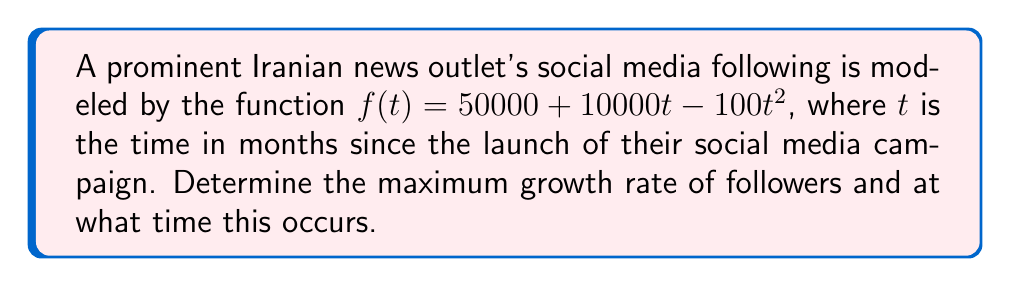Can you answer this question? To solve this problem, we'll follow these steps:

1) The growth rate is given by the derivative of the function. Let's find $f'(t)$:

   $f'(t) = 10000 - 200t$

2) The maximum growth rate will occur when the second derivative equals zero. Let's find $f''(t)$:

   $f''(t) = -200$

3) Since $f''(t)$ is a constant and negative, the function $f(t)$ is concave down, and the maximum growth rate will occur at the beginning of the campaign.

4) To find the maximum growth rate, we evaluate $f'(t)$ at $t=0$:

   $f'(0) = 10000 - 200(0) = 10000$

Therefore, the maximum growth rate is 10,000 followers per month, occurring at the start of the campaign $(t=0)$.

This aligns with the typical pattern of social media growth, where the initial surge of followers is often the highest, gradually slowing down over time.
Answer: 10,000 followers/month at $t=0$ 